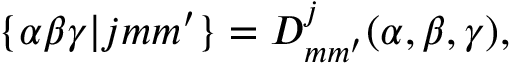Convert formula to latex. <formula><loc_0><loc_0><loc_500><loc_500>\{ \alpha \beta \gamma | j m m ^ { \prime } \} = D _ { m m ^ { \prime } } ^ { j } ( \alpha , \beta , \gamma ) ,</formula> 